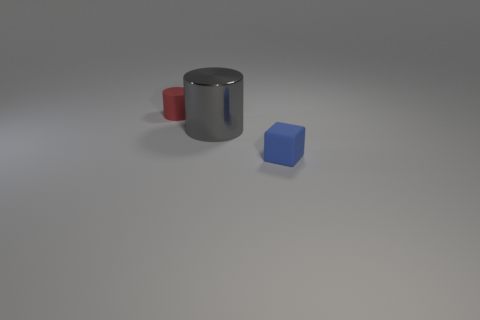Are there any other things that are the same size as the gray metal object?
Your response must be concise. No. How many matte objects are either red things or blocks?
Your response must be concise. 2. Are there any red things that are right of the tiny object in front of the tiny rubber thing that is behind the small blue cube?
Offer a very short reply. No. How many cylinders are right of the red matte cylinder?
Keep it short and to the point. 1. How many small objects are red rubber cylinders or metal things?
Offer a very short reply. 1. What is the shape of the tiny object right of the large gray shiny thing?
Your answer should be compact. Cube. Are there any large cylinders of the same color as the tiny matte cylinder?
Your answer should be very brief. No. There is a cylinder that is right of the red rubber thing; does it have the same size as the cylinder left of the large gray thing?
Give a very brief answer. No. Are there more large gray cylinders in front of the blue matte cube than small matte cylinders in front of the tiny red rubber thing?
Provide a short and direct response. No. Is there a big cyan thing that has the same material as the small cylinder?
Provide a succinct answer. No. 